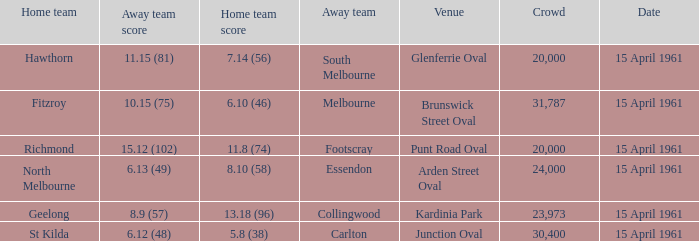Which venue had a home team score of 6.10 (46)? Brunswick Street Oval. 